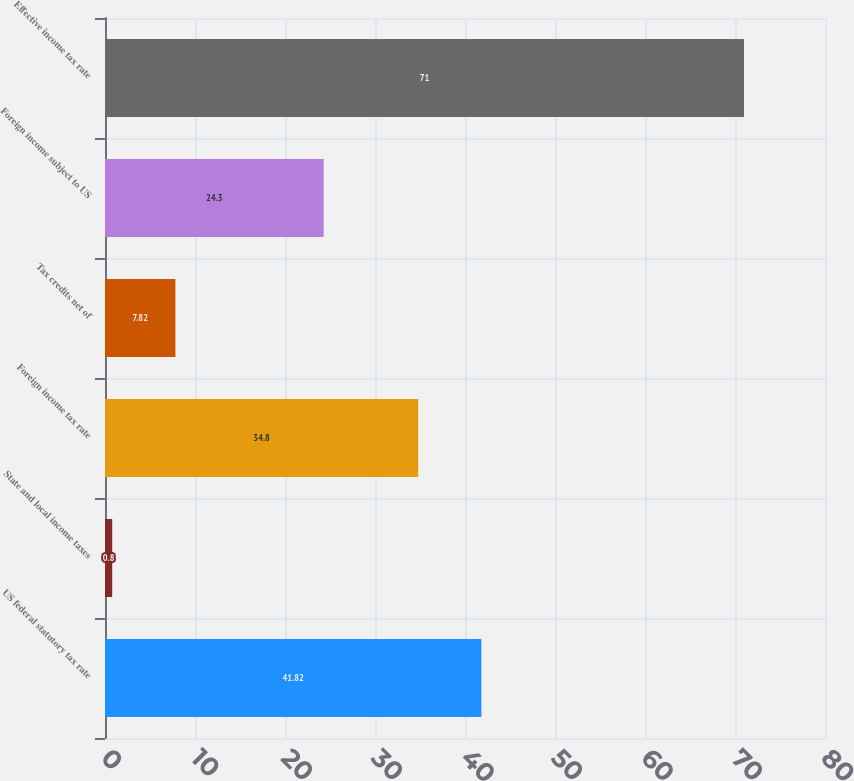Convert chart. <chart><loc_0><loc_0><loc_500><loc_500><bar_chart><fcel>US federal statutory tax rate<fcel>State and local income taxes<fcel>Foreign income tax rate<fcel>Tax credits net of<fcel>Foreign income subject to US<fcel>Effective income tax rate<nl><fcel>41.82<fcel>0.8<fcel>34.8<fcel>7.82<fcel>24.3<fcel>71<nl></chart> 